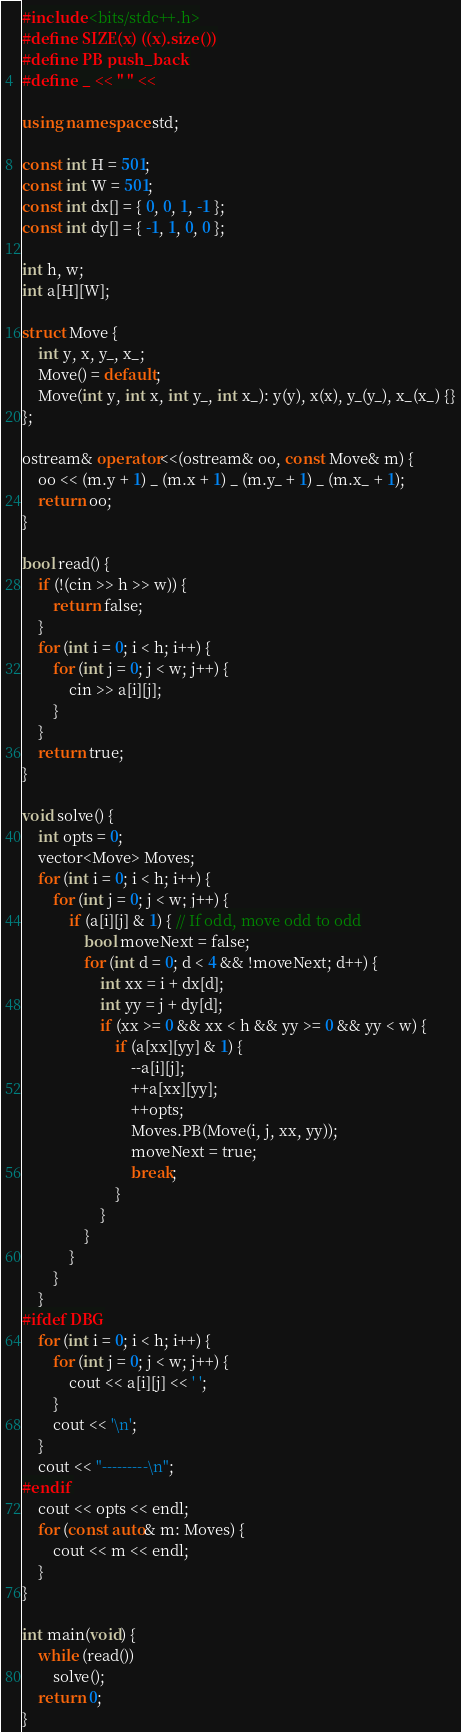Convert code to text. <code><loc_0><loc_0><loc_500><loc_500><_C++_>#include <bits/stdc++.h>
#define SIZE(x) ((x).size())
#define PB push_back
#define _ << " " <<

using namespace std;

const int H = 501;
const int W = 501;
const int dx[] = { 0, 0, 1, -1 };
const int dy[] = { -1, 1, 0, 0 };

int h, w;
int a[H][W];

struct Move {
    int y, x, y_, x_;
    Move() = default;
    Move(int y, int x, int y_, int x_): y(y), x(x), y_(y_), x_(x_) {}
};

ostream& operator<<(ostream& oo, const Move& m) {
    oo << (m.y + 1) _ (m.x + 1) _ (m.y_ + 1) _ (m.x_ + 1);
    return oo;
}

bool read() {
    if (!(cin >> h >> w)) {
        return false;
    }
    for (int i = 0; i < h; i++) {
        for (int j = 0; j < w; j++) {
            cin >> a[i][j];
        }
    }
    return true;
}

void solve() {
    int opts = 0;
    vector<Move> Moves;
    for (int i = 0; i < h; i++) {
        for (int j = 0; j < w; j++) {
            if (a[i][j] & 1) { // If odd, move odd to odd
                bool moveNext = false;
                for (int d = 0; d < 4 && !moveNext; d++) {
                    int xx = i + dx[d];
                    int yy = j + dy[d];
                    if (xx >= 0 && xx < h && yy >= 0 && yy < w) {
                        if (a[xx][yy] & 1) {
                            --a[i][j];
                            ++a[xx][yy];
                            ++opts;
                            Moves.PB(Move(i, j, xx, yy));
                            moveNext = true;
                            break;
                        }
                    }
                }
            }
        }
    }
#ifdef DBG
    for (int i = 0; i < h; i++) {
        for (int j = 0; j < w; j++) {
            cout << a[i][j] << ' ';
        }
        cout << '\n';
    }
    cout << "---------\n";
#endif
    cout << opts << endl;
    for (const auto& m: Moves) {
        cout << m << endl;
    }
}

int main(void) {
    while (read())
        solve();
    return 0;
}
</code> 